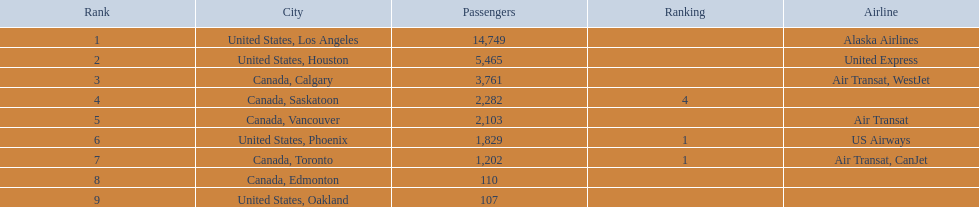Which cities have links to the playa de oro international airport? United States, Los Angeles, United States, Houston, Canada, Calgary, Canada, Saskatoon, Canada, Vancouver, United States, Phoenix, Canada, Toronto, Canada, Edmonton, United States, Oakland. What is the passenger count in the united states, los angeles? 14,749. What other cities' passenger numbers would total about 19,000 when combined with the earlier los angeles? Canada, Calgary. 